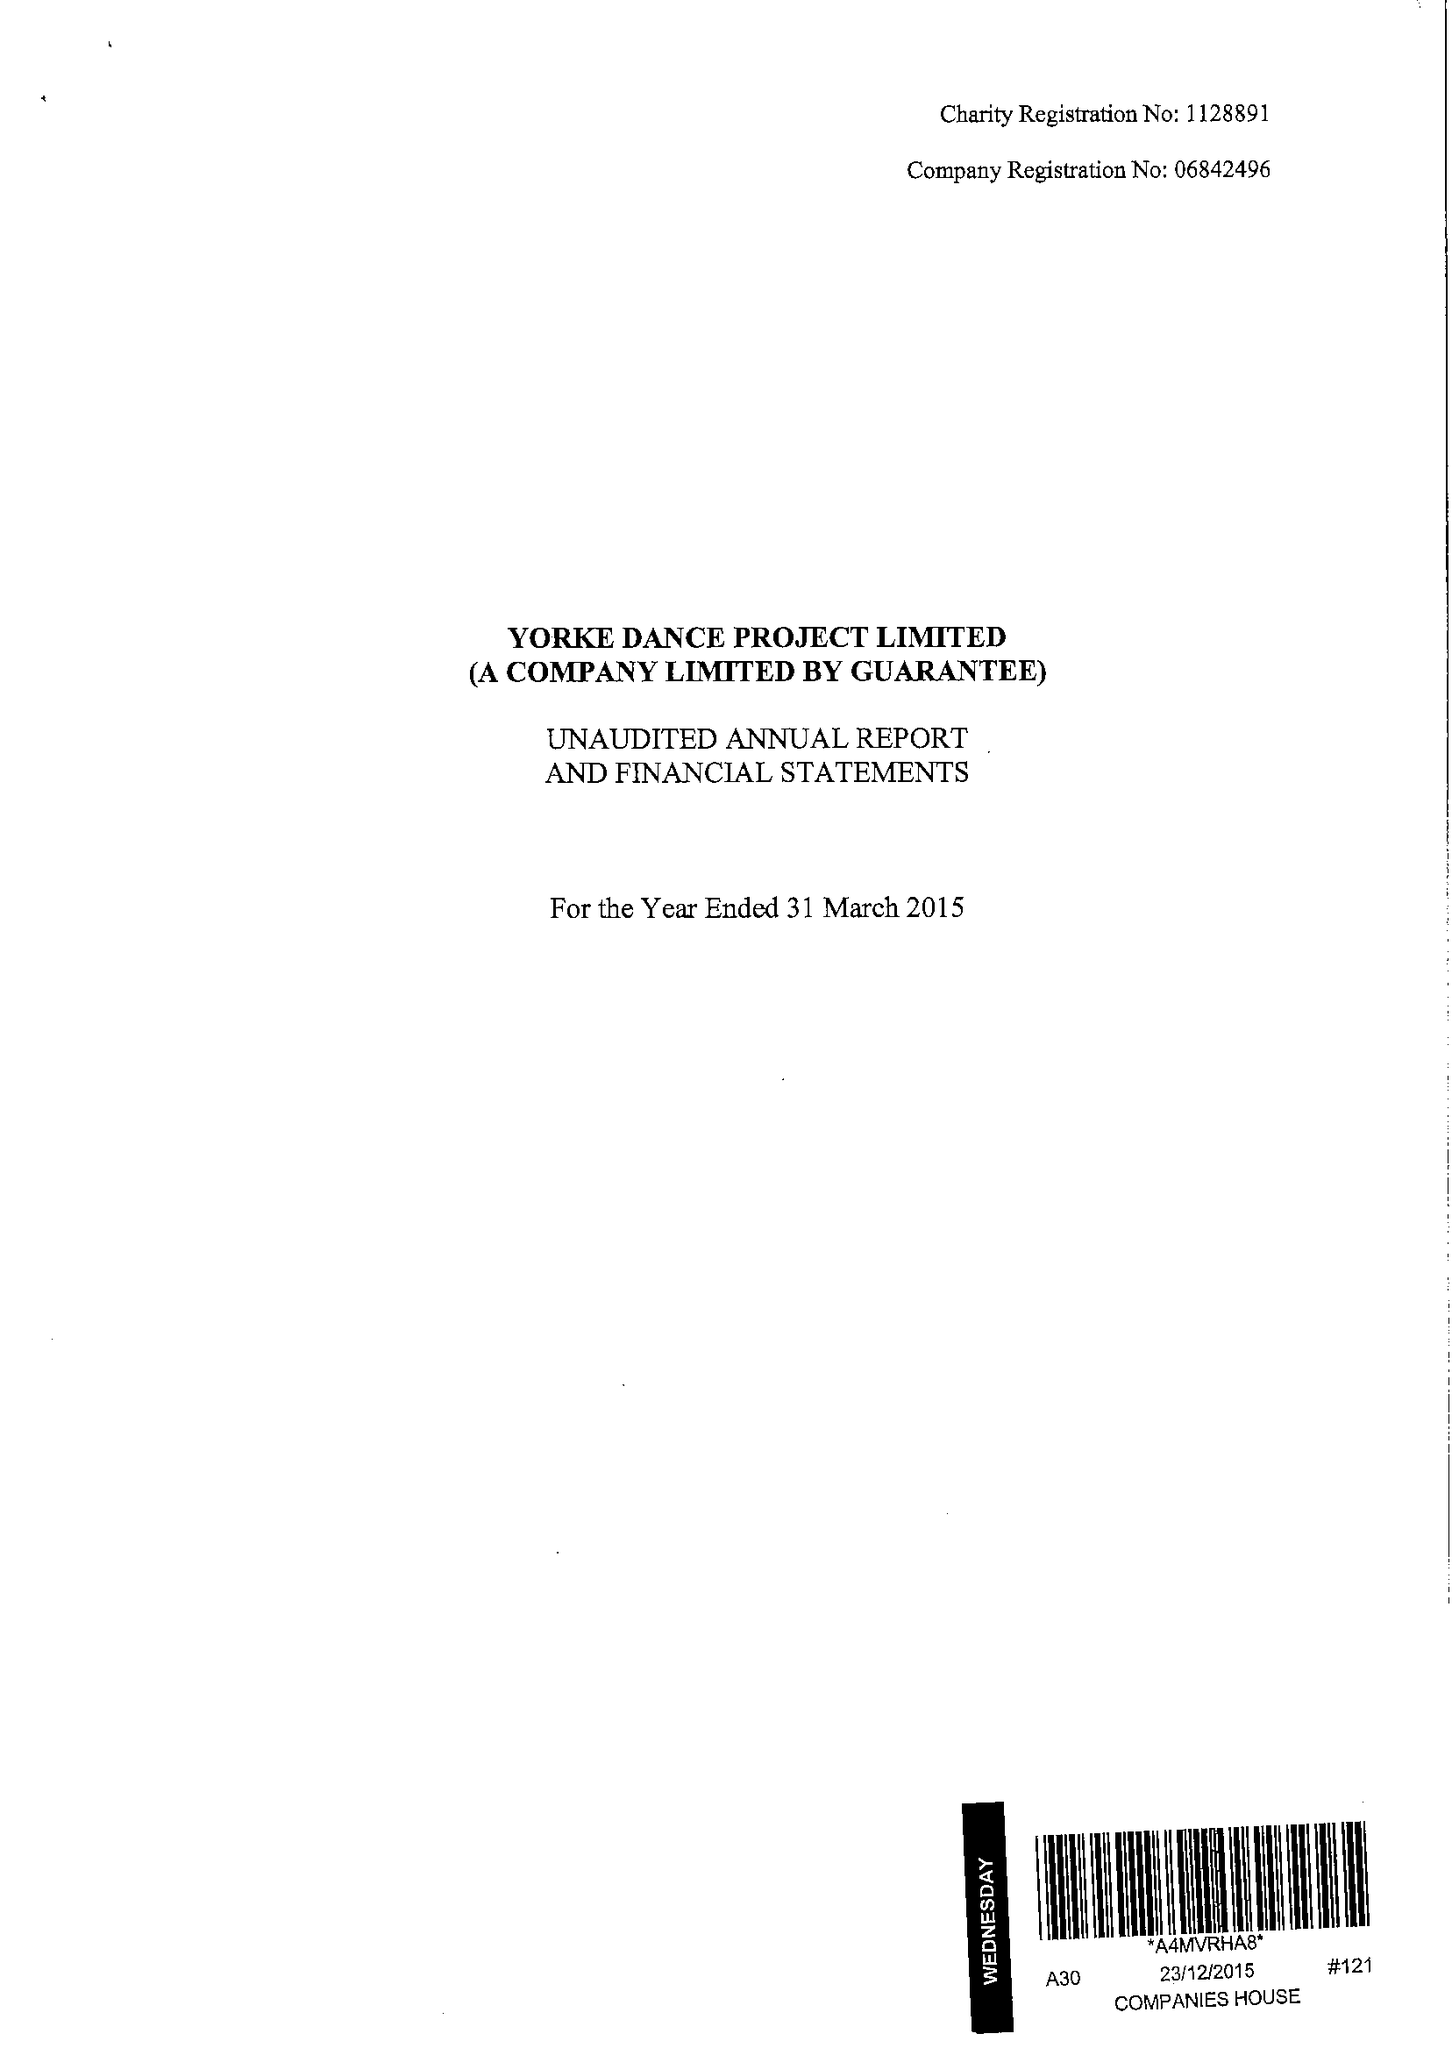What is the value for the address__postcode?
Answer the question using a single word or phrase. SW13 0BL 